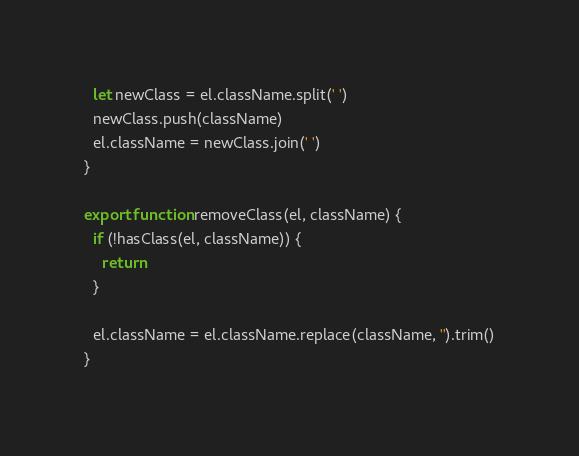Convert code to text. <code><loc_0><loc_0><loc_500><loc_500><_JavaScript_>  let newClass = el.className.split(' ')
  newClass.push(className)
  el.className = newClass.join(' ')
}

export function removeClass(el, className) {
  if (!hasClass(el, className)) {
    return
  }

  el.className = el.className.replace(className, '').trim()
}
</code> 